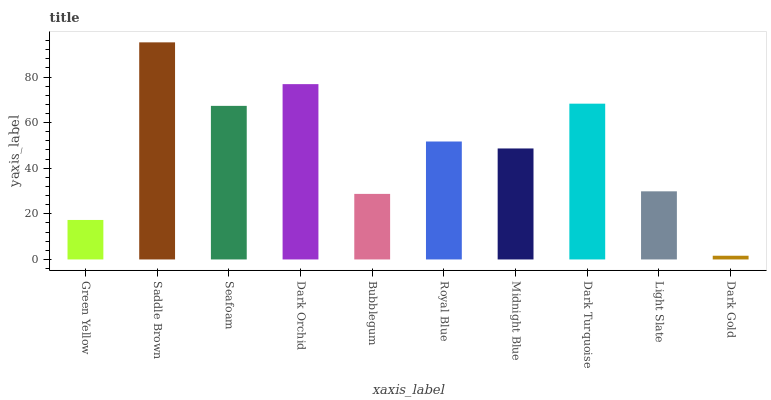Is Seafoam the minimum?
Answer yes or no. No. Is Seafoam the maximum?
Answer yes or no. No. Is Saddle Brown greater than Seafoam?
Answer yes or no. Yes. Is Seafoam less than Saddle Brown?
Answer yes or no. Yes. Is Seafoam greater than Saddle Brown?
Answer yes or no. No. Is Saddle Brown less than Seafoam?
Answer yes or no. No. Is Royal Blue the high median?
Answer yes or no. Yes. Is Midnight Blue the low median?
Answer yes or no. Yes. Is Green Yellow the high median?
Answer yes or no. No. Is Dark Turquoise the low median?
Answer yes or no. No. 